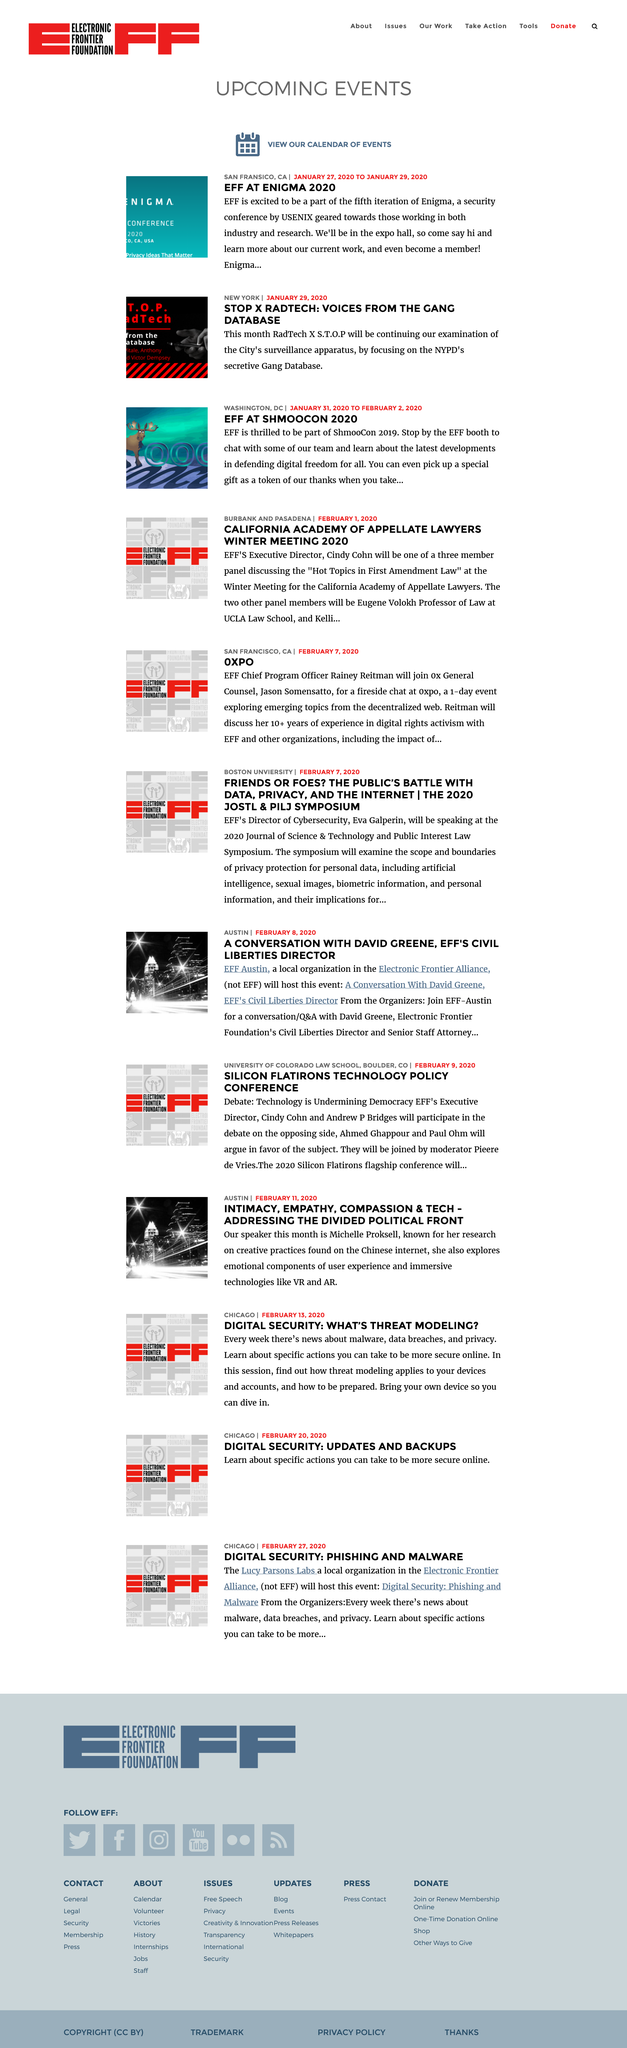Identify some key points in this picture. The NYPD has a secretive Gang Database. The security conference organized by USENIX will be held from January 27th to January 29th, 2020. I, EFF, am delighted to be attending ShmooCon 2019. 